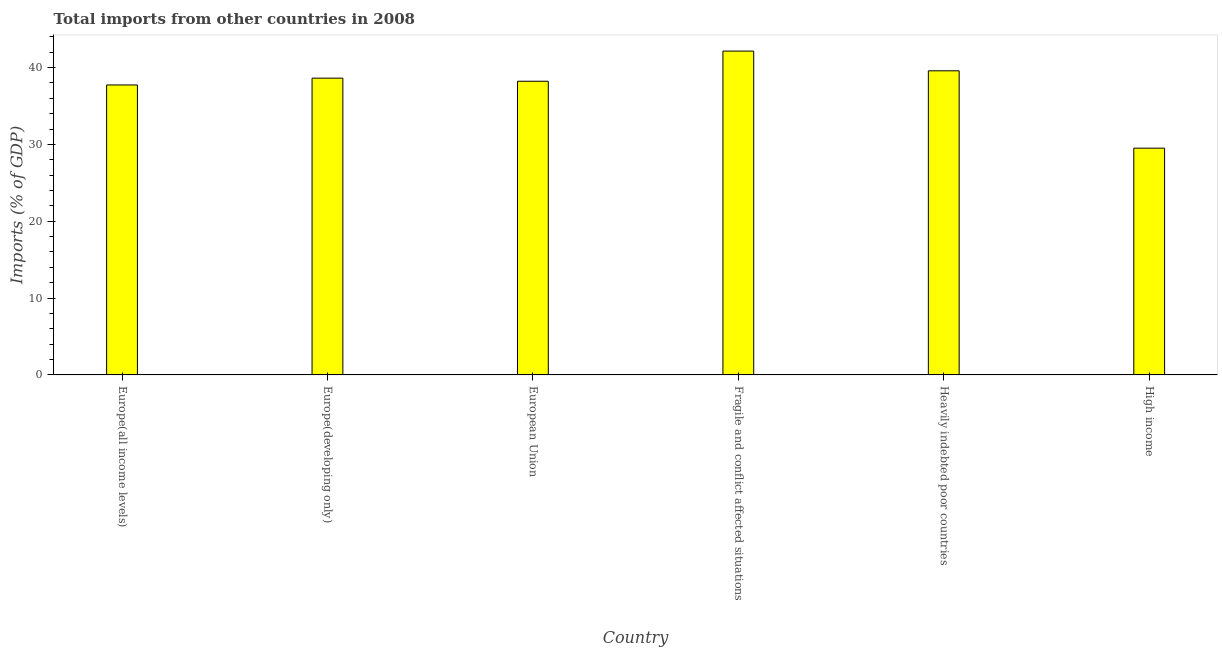Does the graph contain grids?
Offer a very short reply. No. What is the title of the graph?
Your answer should be compact. Total imports from other countries in 2008. What is the label or title of the X-axis?
Offer a very short reply. Country. What is the label or title of the Y-axis?
Offer a terse response. Imports (% of GDP). What is the total imports in European Union?
Give a very brief answer. 38.22. Across all countries, what is the maximum total imports?
Your answer should be very brief. 42.15. Across all countries, what is the minimum total imports?
Make the answer very short. 29.51. In which country was the total imports maximum?
Ensure brevity in your answer.  Fragile and conflict affected situations. What is the sum of the total imports?
Provide a short and direct response. 225.83. What is the difference between the total imports in Europe(all income levels) and Europe(developing only)?
Make the answer very short. -0.89. What is the average total imports per country?
Keep it short and to the point. 37.64. What is the median total imports?
Ensure brevity in your answer.  38.42. What is the ratio of the total imports in Europe(developing only) to that in Heavily indebted poor countries?
Your answer should be compact. 0.98. Is the difference between the total imports in Europe(all income levels) and Heavily indebted poor countries greater than the difference between any two countries?
Provide a succinct answer. No. What is the difference between the highest and the second highest total imports?
Ensure brevity in your answer.  2.57. Is the sum of the total imports in European Union and Fragile and conflict affected situations greater than the maximum total imports across all countries?
Your response must be concise. Yes. What is the difference between the highest and the lowest total imports?
Your answer should be compact. 12.64. In how many countries, is the total imports greater than the average total imports taken over all countries?
Keep it short and to the point. 5. Are all the bars in the graph horizontal?
Make the answer very short. No. What is the difference between two consecutive major ticks on the Y-axis?
Offer a terse response. 10. Are the values on the major ticks of Y-axis written in scientific E-notation?
Your response must be concise. No. What is the Imports (% of GDP) of Europe(all income levels)?
Give a very brief answer. 37.74. What is the Imports (% of GDP) of Europe(developing only)?
Keep it short and to the point. 38.63. What is the Imports (% of GDP) of European Union?
Ensure brevity in your answer.  38.22. What is the Imports (% of GDP) in Fragile and conflict affected situations?
Offer a terse response. 42.15. What is the Imports (% of GDP) of Heavily indebted poor countries?
Your answer should be compact. 39.58. What is the Imports (% of GDP) of High income?
Your response must be concise. 29.51. What is the difference between the Imports (% of GDP) in Europe(all income levels) and Europe(developing only)?
Ensure brevity in your answer.  -0.89. What is the difference between the Imports (% of GDP) in Europe(all income levels) and European Union?
Keep it short and to the point. -0.48. What is the difference between the Imports (% of GDP) in Europe(all income levels) and Fragile and conflict affected situations?
Your answer should be very brief. -4.41. What is the difference between the Imports (% of GDP) in Europe(all income levels) and Heavily indebted poor countries?
Provide a succinct answer. -1.84. What is the difference between the Imports (% of GDP) in Europe(all income levels) and High income?
Your answer should be compact. 8.23. What is the difference between the Imports (% of GDP) in Europe(developing only) and European Union?
Provide a short and direct response. 0.4. What is the difference between the Imports (% of GDP) in Europe(developing only) and Fragile and conflict affected situations?
Keep it short and to the point. -3.52. What is the difference between the Imports (% of GDP) in Europe(developing only) and Heavily indebted poor countries?
Offer a terse response. -0.96. What is the difference between the Imports (% of GDP) in Europe(developing only) and High income?
Make the answer very short. 9.11. What is the difference between the Imports (% of GDP) in European Union and Fragile and conflict affected situations?
Ensure brevity in your answer.  -3.93. What is the difference between the Imports (% of GDP) in European Union and Heavily indebted poor countries?
Give a very brief answer. -1.36. What is the difference between the Imports (% of GDP) in European Union and High income?
Provide a short and direct response. 8.71. What is the difference between the Imports (% of GDP) in Fragile and conflict affected situations and Heavily indebted poor countries?
Your answer should be very brief. 2.57. What is the difference between the Imports (% of GDP) in Fragile and conflict affected situations and High income?
Make the answer very short. 12.64. What is the difference between the Imports (% of GDP) in Heavily indebted poor countries and High income?
Your answer should be compact. 10.07. What is the ratio of the Imports (% of GDP) in Europe(all income levels) to that in European Union?
Offer a very short reply. 0.99. What is the ratio of the Imports (% of GDP) in Europe(all income levels) to that in Fragile and conflict affected situations?
Provide a succinct answer. 0.9. What is the ratio of the Imports (% of GDP) in Europe(all income levels) to that in Heavily indebted poor countries?
Offer a terse response. 0.95. What is the ratio of the Imports (% of GDP) in Europe(all income levels) to that in High income?
Your answer should be very brief. 1.28. What is the ratio of the Imports (% of GDP) in Europe(developing only) to that in Fragile and conflict affected situations?
Ensure brevity in your answer.  0.92. What is the ratio of the Imports (% of GDP) in Europe(developing only) to that in High income?
Make the answer very short. 1.31. What is the ratio of the Imports (% of GDP) in European Union to that in Fragile and conflict affected situations?
Keep it short and to the point. 0.91. What is the ratio of the Imports (% of GDP) in European Union to that in Heavily indebted poor countries?
Keep it short and to the point. 0.97. What is the ratio of the Imports (% of GDP) in European Union to that in High income?
Your answer should be compact. 1.29. What is the ratio of the Imports (% of GDP) in Fragile and conflict affected situations to that in Heavily indebted poor countries?
Offer a terse response. 1.06. What is the ratio of the Imports (% of GDP) in Fragile and conflict affected situations to that in High income?
Your answer should be very brief. 1.43. What is the ratio of the Imports (% of GDP) in Heavily indebted poor countries to that in High income?
Provide a short and direct response. 1.34. 